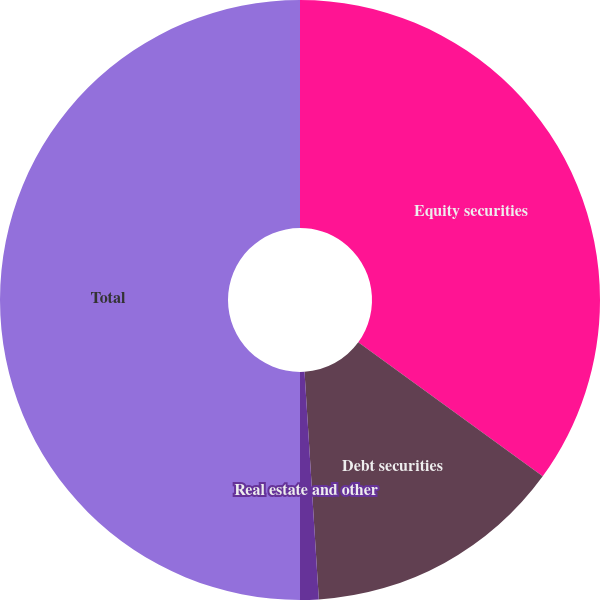<chart> <loc_0><loc_0><loc_500><loc_500><pie_chart><fcel>Equity securities<fcel>Debt securities<fcel>Real estate and other<fcel>Total<nl><fcel>35.0%<fcel>14.0%<fcel>1.0%<fcel>50.0%<nl></chart> 